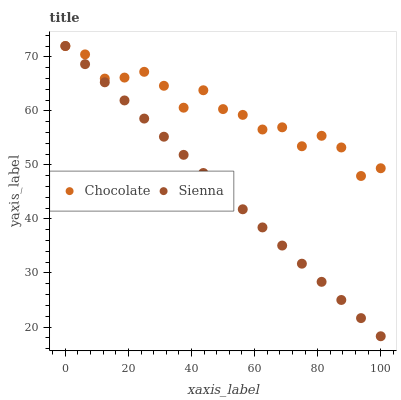Does Sienna have the minimum area under the curve?
Answer yes or no. Yes. Does Chocolate have the maximum area under the curve?
Answer yes or no. Yes. Does Chocolate have the minimum area under the curve?
Answer yes or no. No. Is Sienna the smoothest?
Answer yes or no. Yes. Is Chocolate the roughest?
Answer yes or no. Yes. Is Chocolate the smoothest?
Answer yes or no. No. Does Sienna have the lowest value?
Answer yes or no. Yes. Does Chocolate have the lowest value?
Answer yes or no. No. Does Chocolate have the highest value?
Answer yes or no. Yes. Does Sienna intersect Chocolate?
Answer yes or no. Yes. Is Sienna less than Chocolate?
Answer yes or no. No. Is Sienna greater than Chocolate?
Answer yes or no. No. 